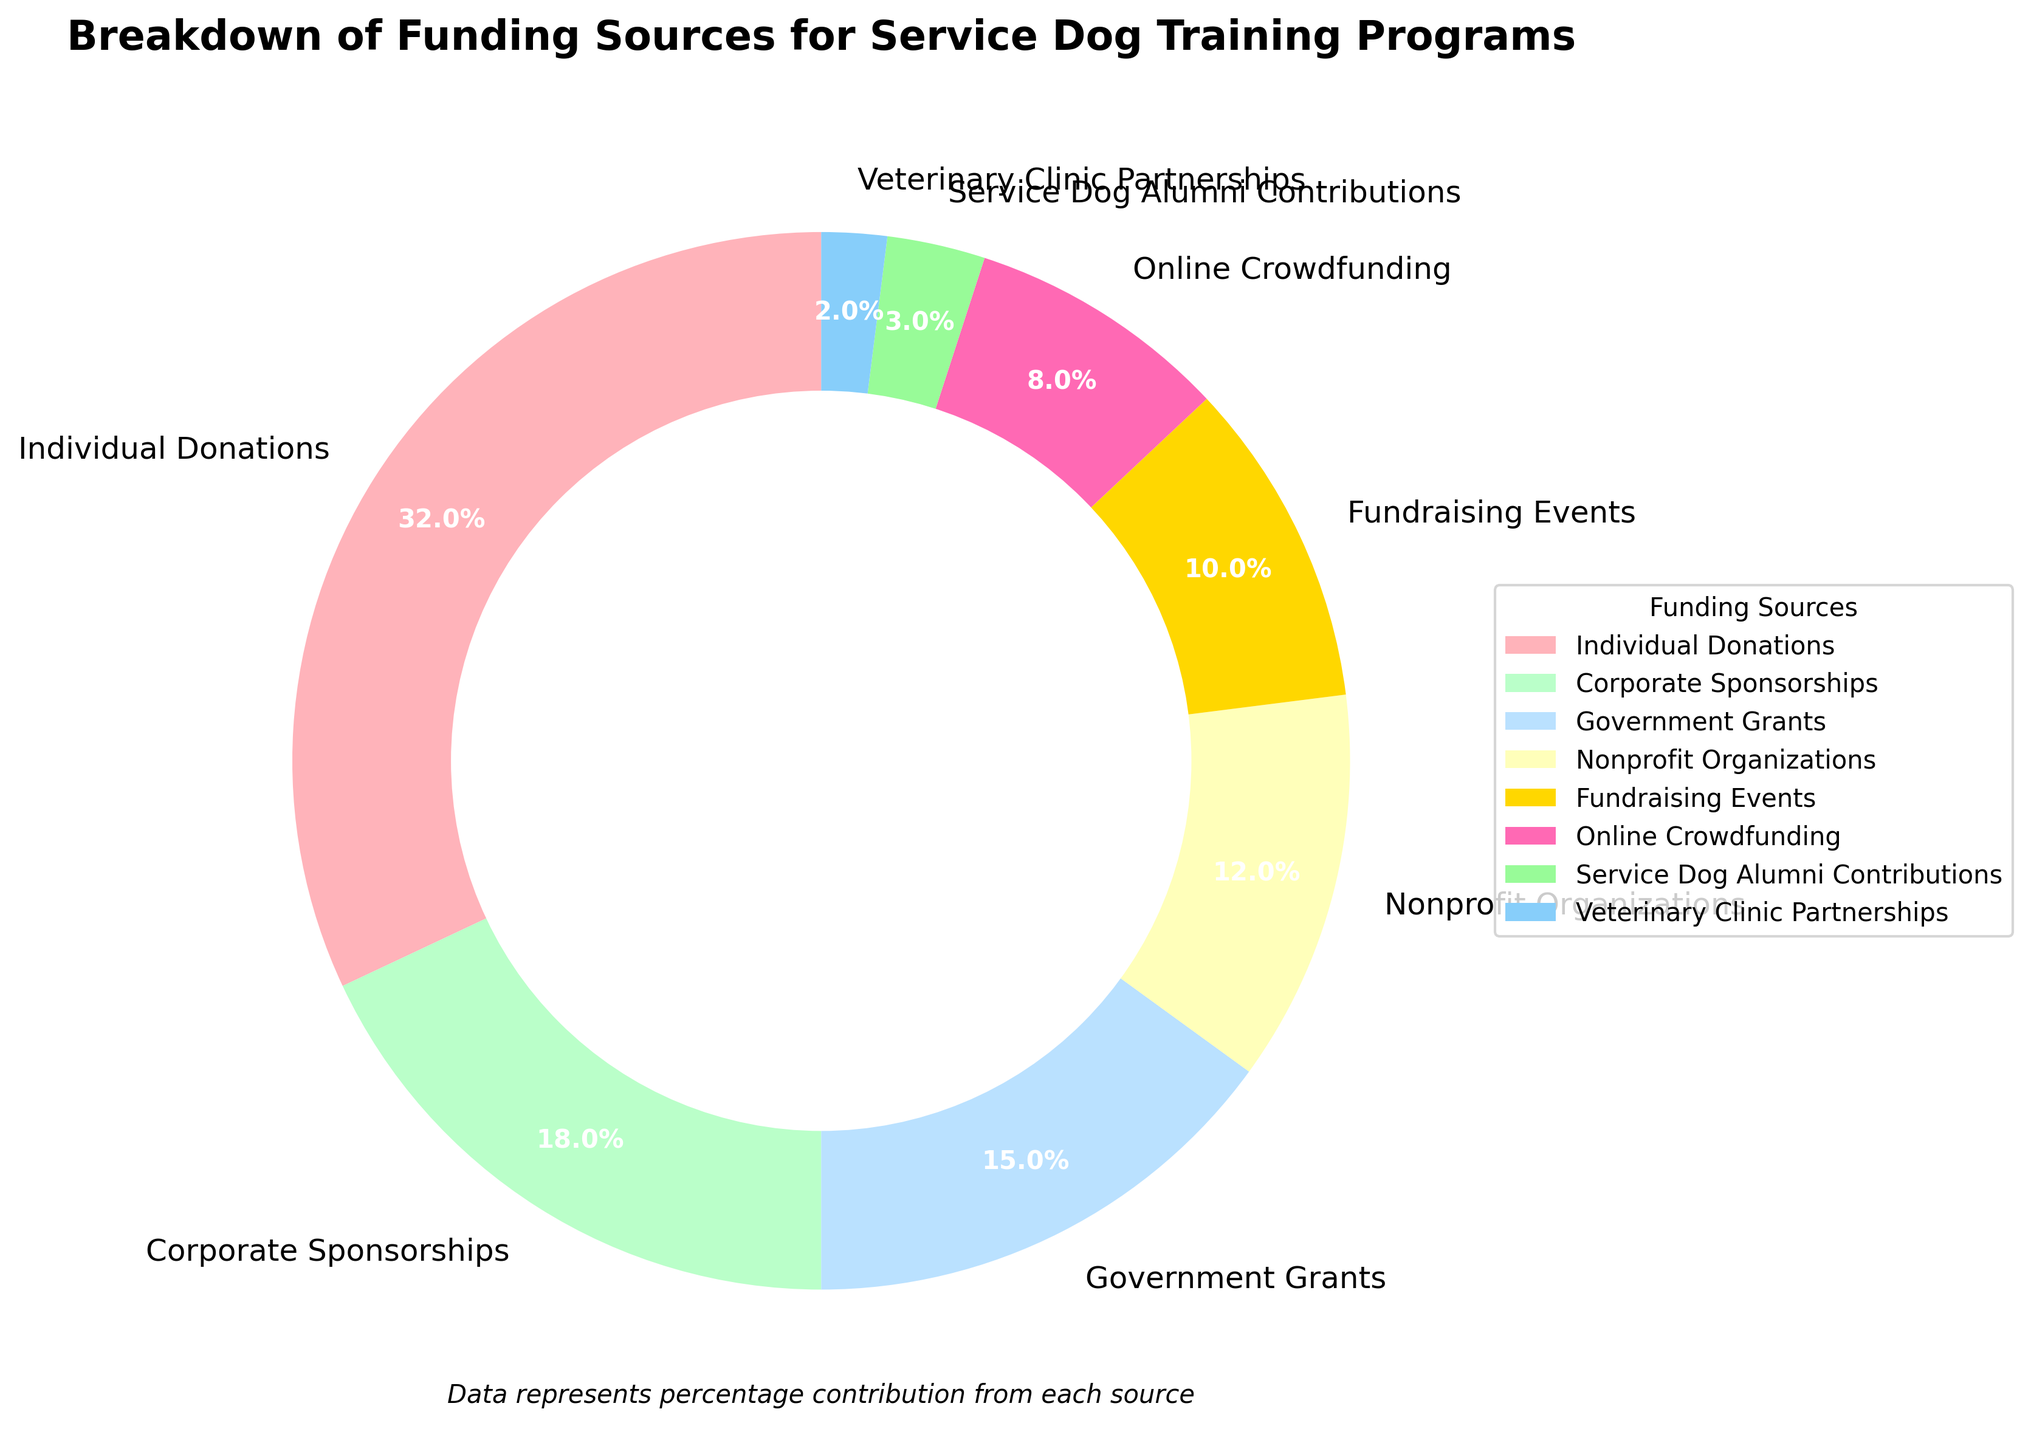What is the largest funding source for service dog training programs? To find the largest funding source, look for the segment with the highest percentage. "Individual Donations" has the largest percentage at 32%.
Answer: Individual Donations Which funding source has a smaller percentage, Corporate Sponsorships or Government Grants? Compare the percentages for Corporate Sponsorships and Government Grants. Corporate Sponsorships are at 18%, while Government Grants are at 15%, which means Government Grants have a smaller percentage.
Answer: Government Grants How does the percentage of Online Crowdfunding compare to that of Fundraising Events? Look at the percentages of both funding sources. Online Crowdfunding is 8%, while Fundraising Events are 10%. Therefore, Online Crowdfunding has a smaller percentage compared to Fundraising Events.
Answer: Online Crowdfunding is smaller What is the sum of the percentages for Individual Donations and Corporate Sponsorships? Add the percentages of Individual Donations (32%) and Corporate Sponsorships (18%). 32% + 18% equals 50%.
Answer: 50% By what percentage does the contribution from Fundraising Events exceed that of Veterinary Clinic Partnerships? Subtract the percentage of Veterinary Clinic Partnerships (2%) from the percentage of Fundraising Events (10%). 10% - 2% equals 8%.
Answer: 8% Which two funding sources contribute to 20% of the total funding combined? Adding Online Crowdfunding (8%) and Fundraising Events (10%) gives 18%. Checking other combinations, Nonprofit Organizations at 12% and Veterinary Clinic Partnerships at 2% totals to 14%. Finally, adding Nonprofit Organizations at 12% and Service Dog Alumni Contributions at 3% gives 15%. Therefore, no pairs exactly match 20%.
Answer: None Which wedge has a magenta/pinkish tint in the pie chart? The pie chart uses distinct colors for each segment. The wedge with a magenta/pinkish tint represents "Individual Donations."
Answer: Individual Donations What is the combined percentage of Nonprofit Organizations and Government Grants? Add the percentages of Nonprofit Organizations (12%) and Government Grants (15%). 12% + 15% equals 27%.
Answer: 27% Arrange the sources in descending order based on their contribution percentages. Sort the funding sources by their percentages from highest to lowest: Individual Donations (32%), Corporate Sponsorships (18%), Government Grants (15%), Nonprofit Organizations (12%), Fundraising Events (10%), Online Crowdfunding (8%), Service Dog Alumni Contributions (3%), Veterinary Clinic Partnerships (2%).
Answer: Individual Donations, Corporate Sponsorships, Government Grants, Nonprofit Organizations, Fundraising Events, Online Crowdfunding, Service Dog Alumni Contributions, Veterinary Clinic Partnerships What percentage do the four smallest funding sources contribute in total? Combine the percentages of Service Dog Alumni Contributions (3%), Online Crowdfunding (8%), Fundraising Events (10%), and Veterinary Clinic Partnerships (2%). 3% + 8% + 10% + 2% equals 23%.
Answer: 23% 